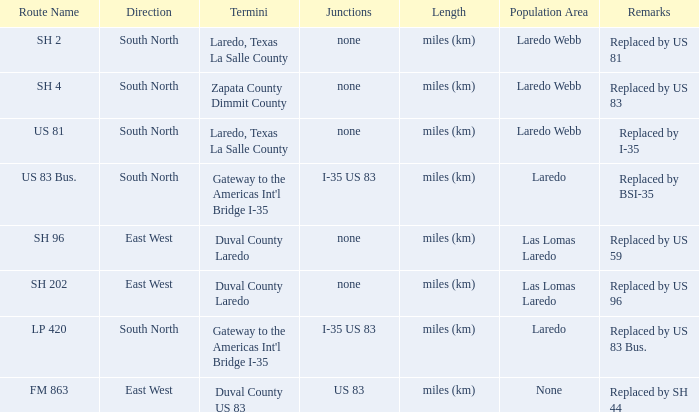What length unit is applied for the course with "replaced by us 81" in their notes section? Miles (km). 